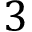<formula> <loc_0><loc_0><loc_500><loc_500>3</formula> 